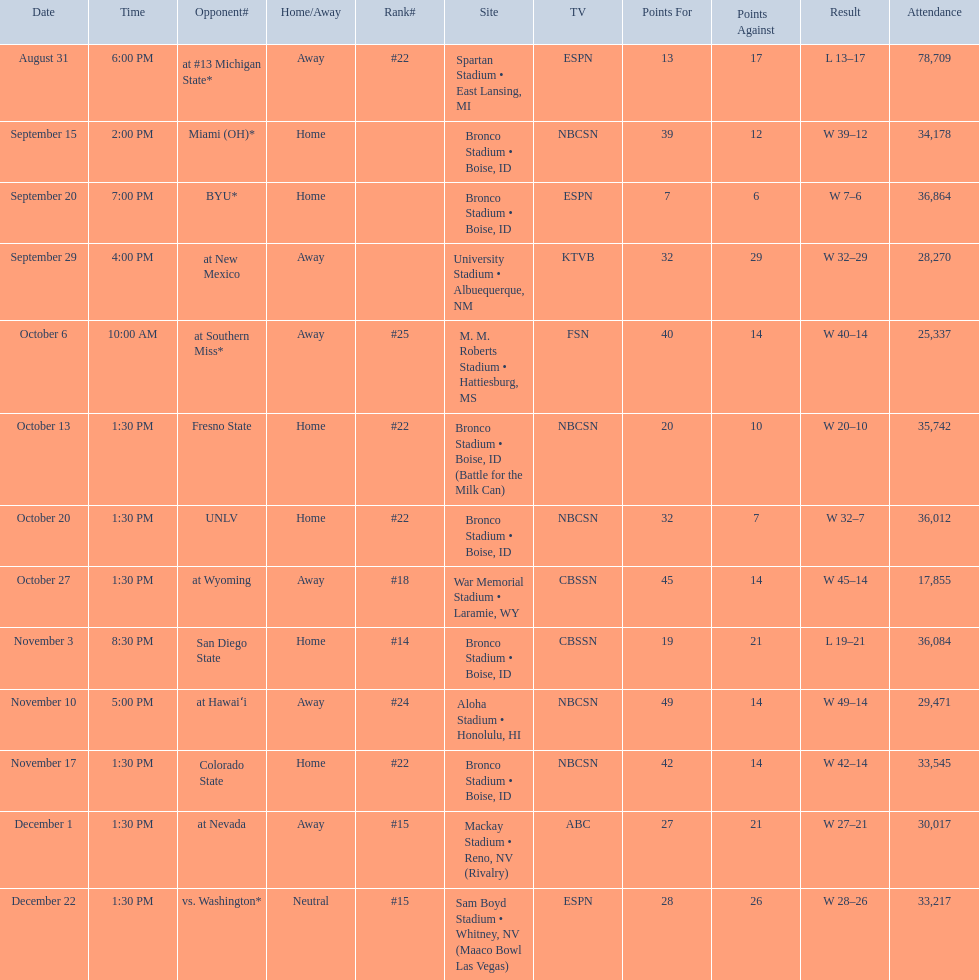Number of points scored by miami (oh) against the broncos. 12. 